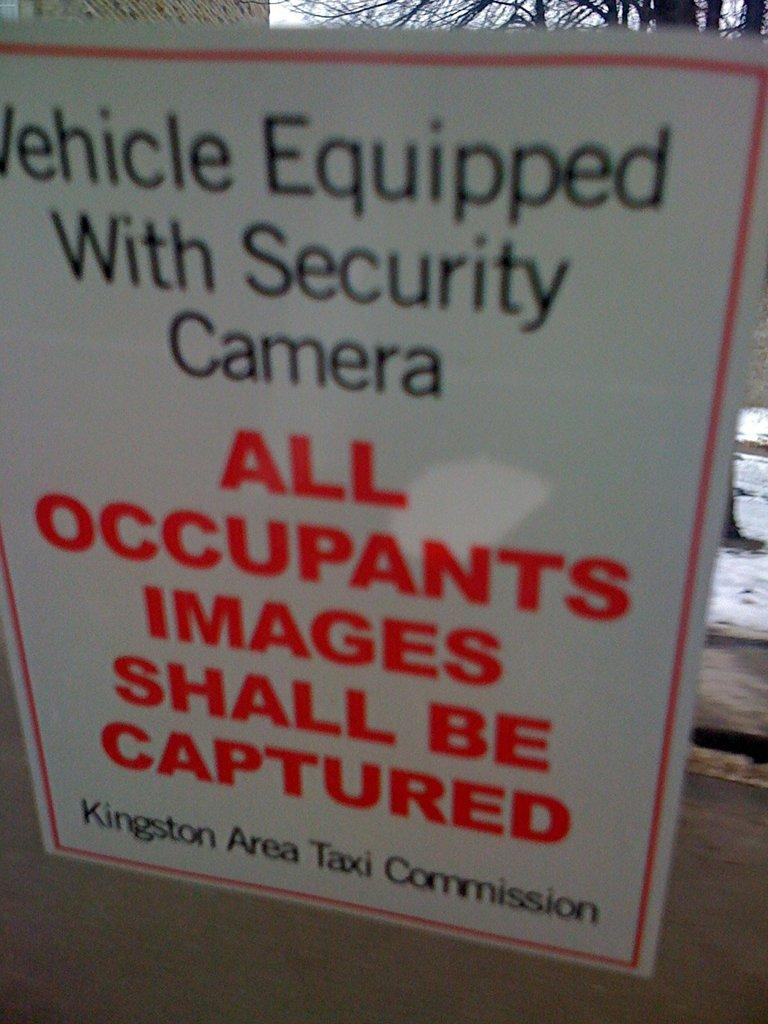<image>
Render a clear and concise summary of the photo. A security sign warns that your image will be captured by security cameras. 